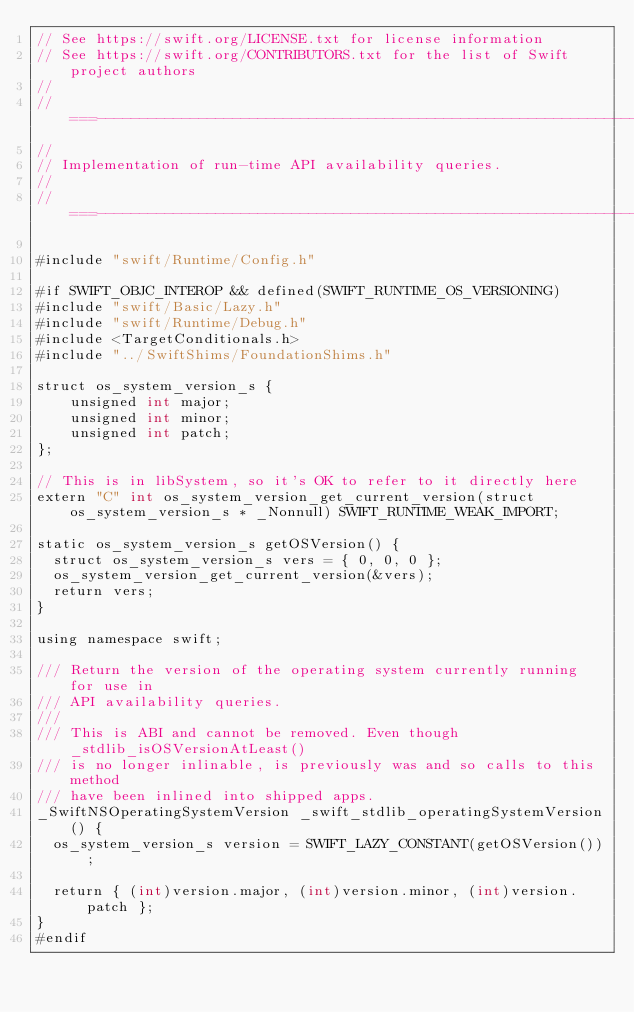<code> <loc_0><loc_0><loc_500><loc_500><_ObjectiveC_>// See https://swift.org/LICENSE.txt for license information
// See https://swift.org/CONTRIBUTORS.txt for the list of Swift project authors
//
//===----------------------------------------------------------------------===//
//
// Implementation of run-time API availability queries.
//
//===----------------------------------------------------------------------===//

#include "swift/Runtime/Config.h"

#if SWIFT_OBJC_INTEROP && defined(SWIFT_RUNTIME_OS_VERSIONING)
#include "swift/Basic/Lazy.h"
#include "swift/Runtime/Debug.h"
#include <TargetConditionals.h>
#include "../SwiftShims/FoundationShims.h"

struct os_system_version_s {
    unsigned int major;
    unsigned int minor;
    unsigned int patch;
};

// This is in libSystem, so it's OK to refer to it directly here
extern "C" int os_system_version_get_current_version(struct os_system_version_s * _Nonnull) SWIFT_RUNTIME_WEAK_IMPORT;

static os_system_version_s getOSVersion() {
  struct os_system_version_s vers = { 0, 0, 0 };
  os_system_version_get_current_version(&vers);
  return vers;
}

using namespace swift;

/// Return the version of the operating system currently running for use in
/// API availability queries.
///
/// This is ABI and cannot be removed. Even though _stdlib_isOSVersionAtLeast()
/// is no longer inlinable, is previously was and so calls to this method
/// have been inlined into shipped apps.
_SwiftNSOperatingSystemVersion _swift_stdlib_operatingSystemVersion() {
  os_system_version_s version = SWIFT_LAZY_CONSTANT(getOSVersion());

  return { (int)version.major, (int)version.minor, (int)version.patch };
}
#endif

</code> 